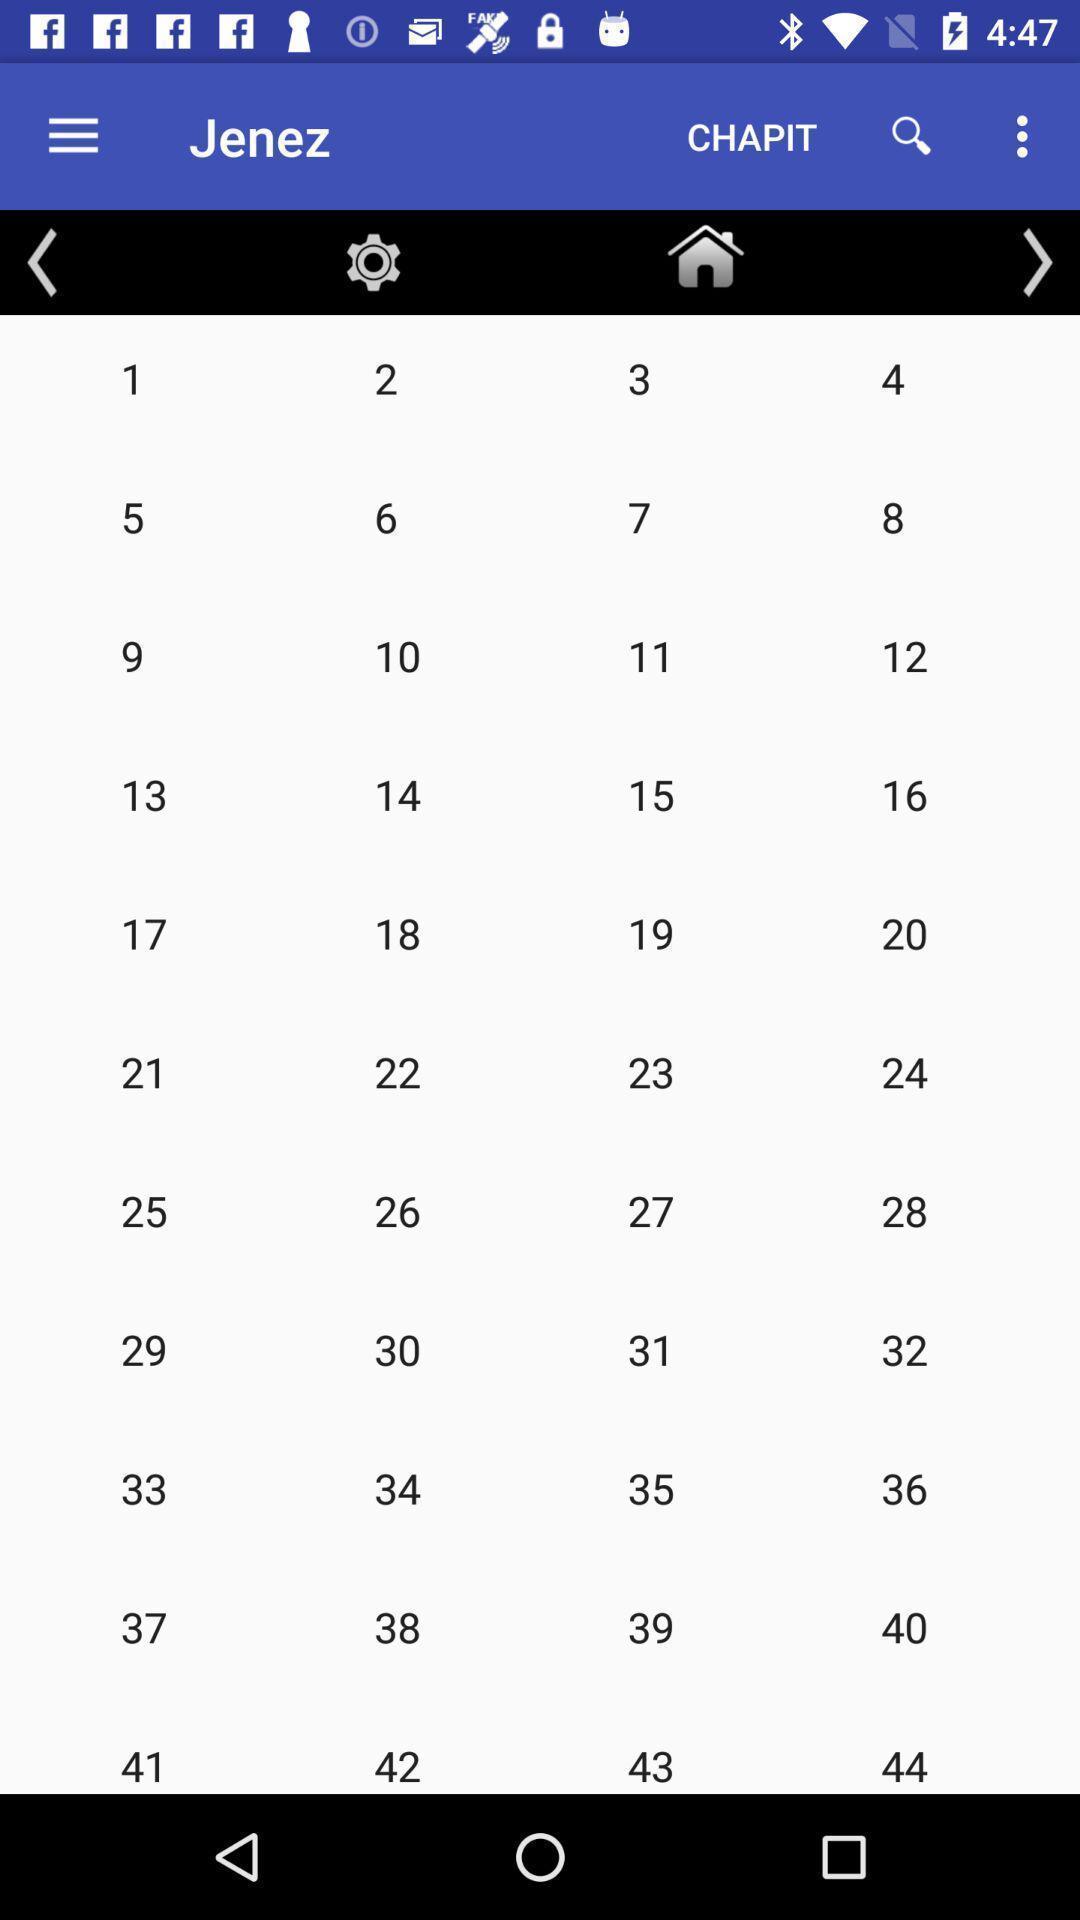Tell me what you see in this picture. Window displaying chapters of bible. 